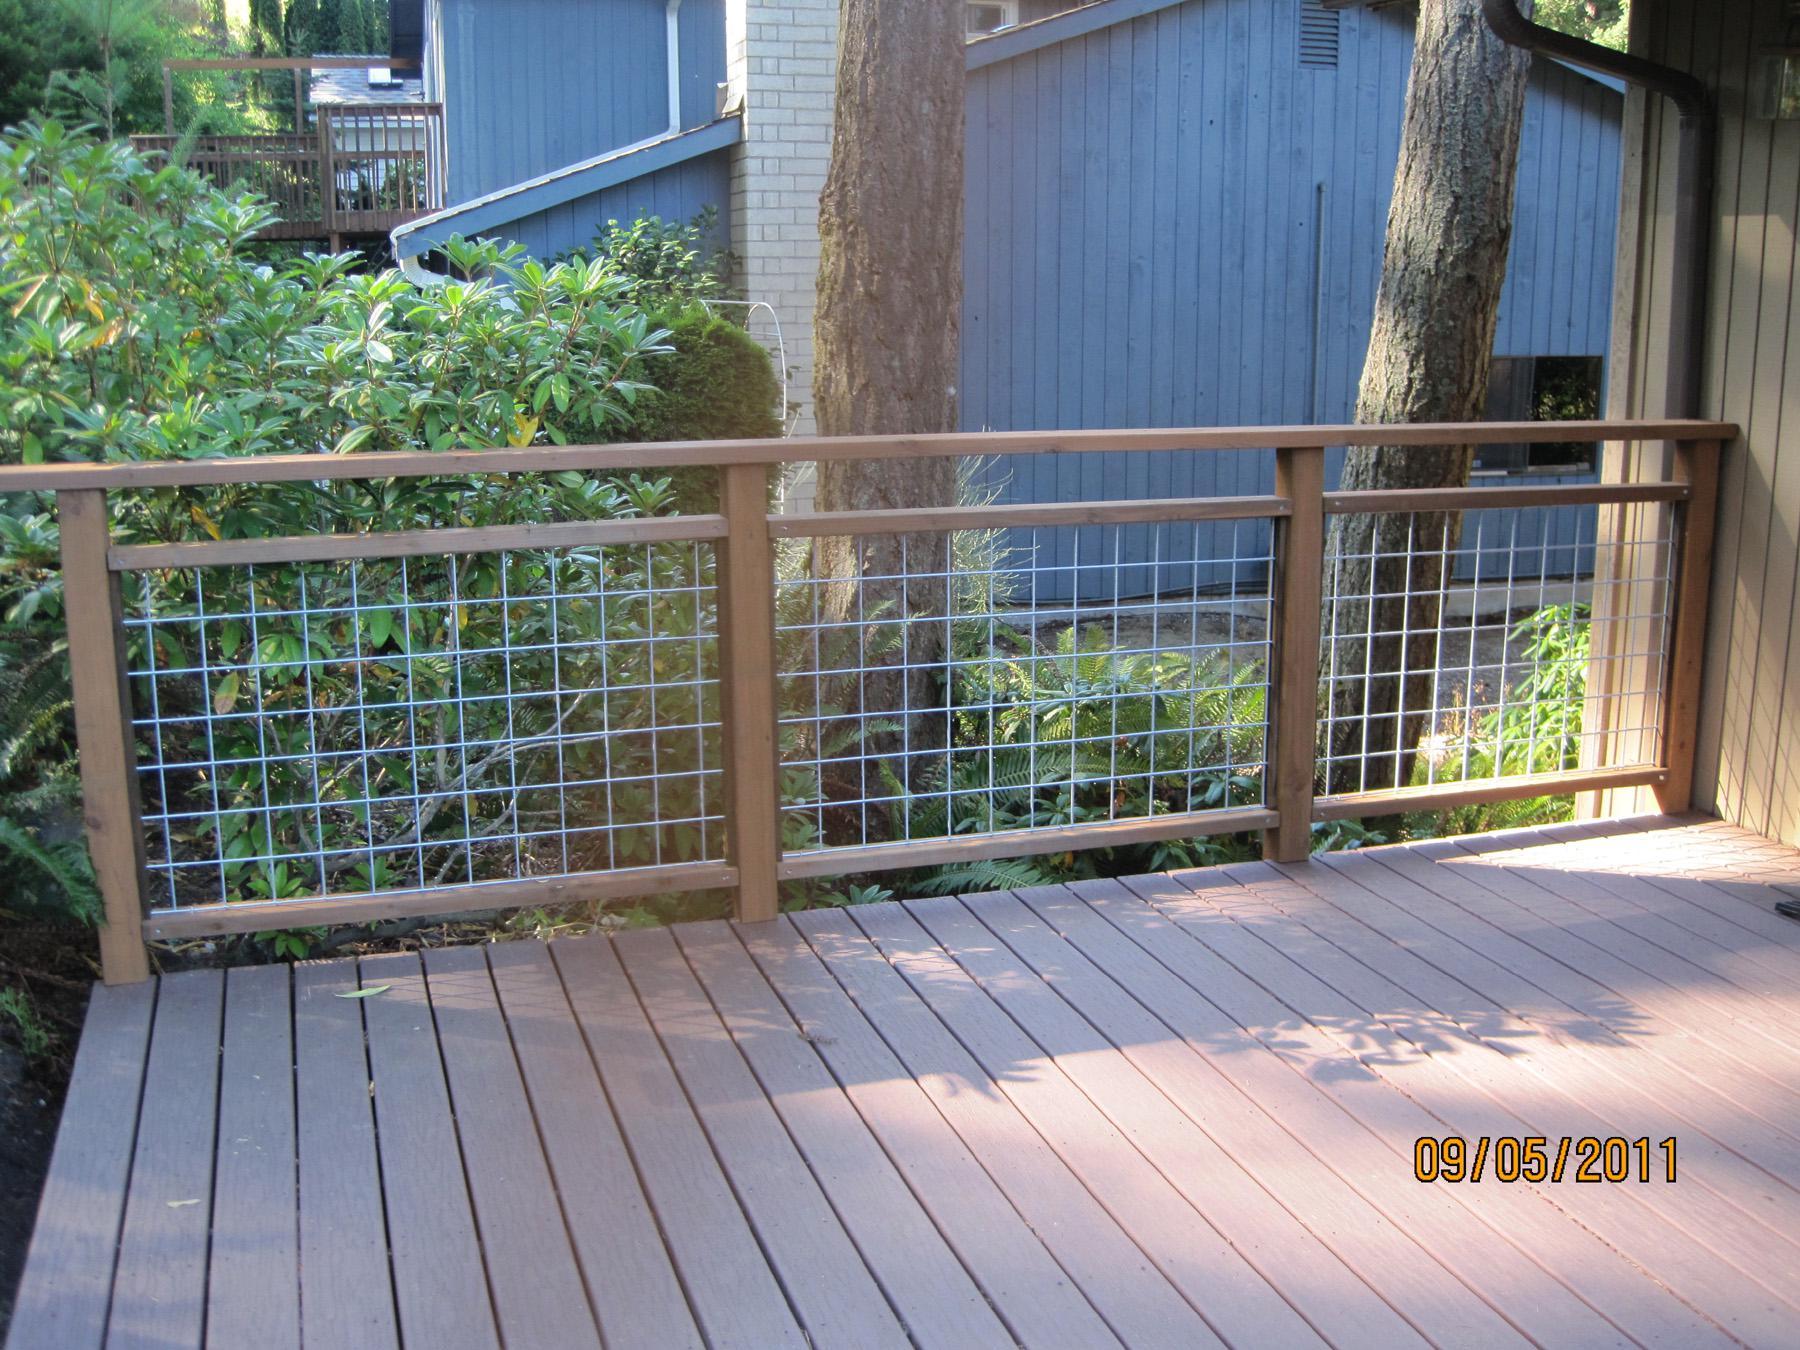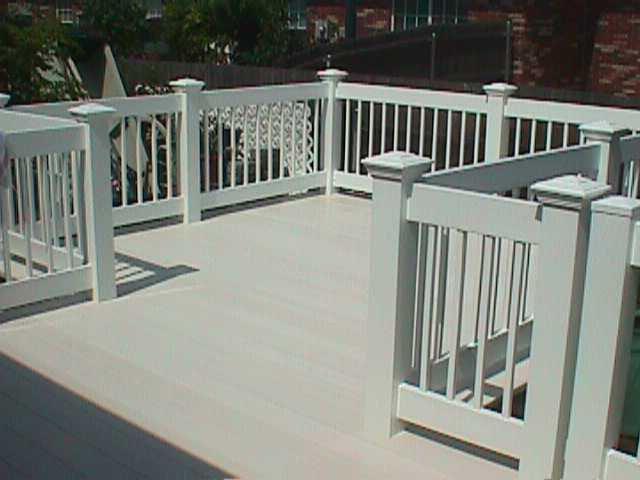The first image is the image on the left, the second image is the image on the right. Considering the images on both sides, is "The left image contains a deck with unpainted wood rails with mesh sides, and the right image shows a deck with light painted vertical rails with square-capped posts." valid? Answer yes or no. Yes. The first image is the image on the left, the second image is the image on the right. Given the left and right images, does the statement "At least one railing is white." hold true? Answer yes or no. No. 